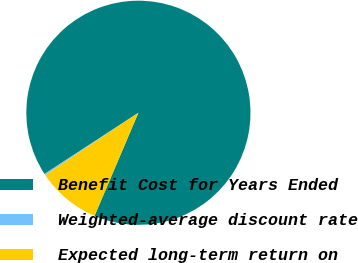Convert chart. <chart><loc_0><loc_0><loc_500><loc_500><pie_chart><fcel>Benefit Cost for Years Ended<fcel>Weighted-average discount rate<fcel>Expected long-term return on<nl><fcel>90.6%<fcel>0.18%<fcel>9.22%<nl></chart> 